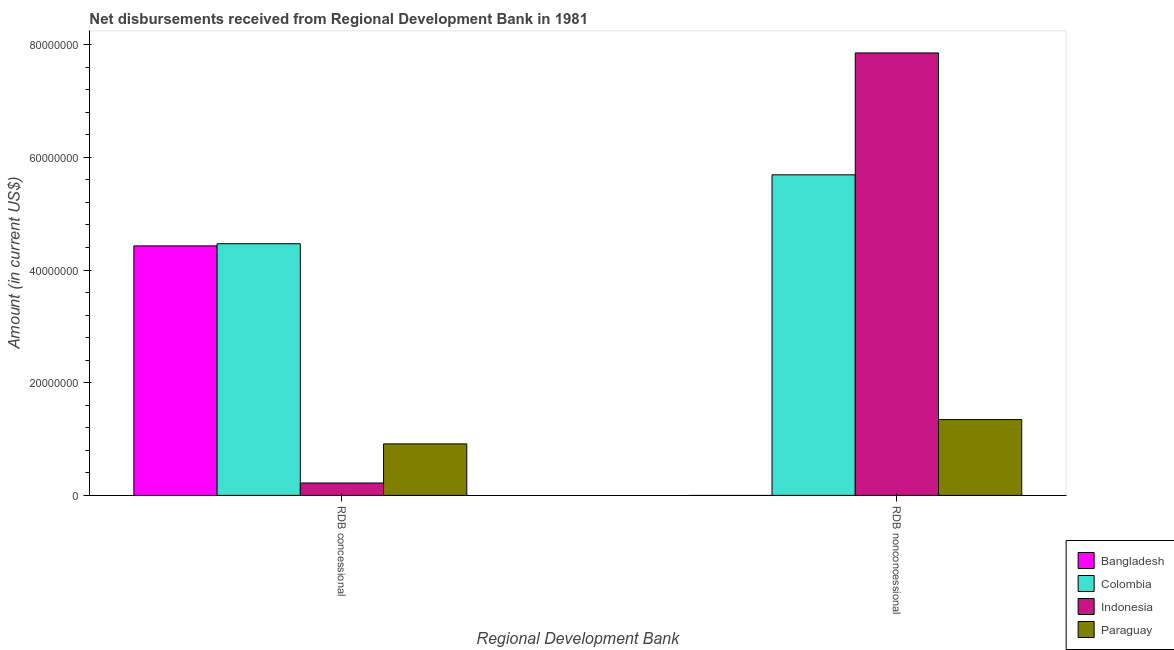How many different coloured bars are there?
Provide a short and direct response. 4. How many bars are there on the 2nd tick from the right?
Give a very brief answer. 4. What is the label of the 2nd group of bars from the left?
Offer a terse response. RDB nonconcessional. What is the net non concessional disbursements from rdb in Indonesia?
Make the answer very short. 7.85e+07. Across all countries, what is the maximum net non concessional disbursements from rdb?
Give a very brief answer. 7.85e+07. What is the total net concessional disbursements from rdb in the graph?
Your answer should be compact. 1.00e+08. What is the difference between the net non concessional disbursements from rdb in Colombia and that in Paraguay?
Ensure brevity in your answer.  4.34e+07. What is the difference between the net non concessional disbursements from rdb in Bangladesh and the net concessional disbursements from rdb in Colombia?
Offer a very short reply. -4.47e+07. What is the average net non concessional disbursements from rdb per country?
Ensure brevity in your answer.  3.72e+07. What is the difference between the net non concessional disbursements from rdb and net concessional disbursements from rdb in Paraguay?
Offer a very short reply. 4.32e+06. What is the ratio of the net concessional disbursements from rdb in Paraguay to that in Bangladesh?
Offer a terse response. 0.21. In how many countries, is the net non concessional disbursements from rdb greater than the average net non concessional disbursements from rdb taken over all countries?
Offer a terse response. 2. How many bars are there?
Your response must be concise. 7. How many countries are there in the graph?
Your response must be concise. 4. Does the graph contain any zero values?
Ensure brevity in your answer.  Yes. Where does the legend appear in the graph?
Provide a succinct answer. Bottom right. How many legend labels are there?
Provide a succinct answer. 4. How are the legend labels stacked?
Your answer should be very brief. Vertical. What is the title of the graph?
Keep it short and to the point. Net disbursements received from Regional Development Bank in 1981. Does "Mexico" appear as one of the legend labels in the graph?
Ensure brevity in your answer.  No. What is the label or title of the X-axis?
Keep it short and to the point. Regional Development Bank. What is the Amount (in current US$) of Bangladesh in RDB concessional?
Your answer should be compact. 4.43e+07. What is the Amount (in current US$) of Colombia in RDB concessional?
Your response must be concise. 4.47e+07. What is the Amount (in current US$) of Indonesia in RDB concessional?
Provide a succinct answer. 2.20e+06. What is the Amount (in current US$) in Paraguay in RDB concessional?
Provide a succinct answer. 9.14e+06. What is the Amount (in current US$) in Bangladesh in RDB nonconcessional?
Ensure brevity in your answer.  0. What is the Amount (in current US$) of Colombia in RDB nonconcessional?
Offer a terse response. 5.69e+07. What is the Amount (in current US$) in Indonesia in RDB nonconcessional?
Ensure brevity in your answer.  7.85e+07. What is the Amount (in current US$) of Paraguay in RDB nonconcessional?
Your response must be concise. 1.35e+07. Across all Regional Development Bank, what is the maximum Amount (in current US$) in Bangladesh?
Your answer should be compact. 4.43e+07. Across all Regional Development Bank, what is the maximum Amount (in current US$) in Colombia?
Ensure brevity in your answer.  5.69e+07. Across all Regional Development Bank, what is the maximum Amount (in current US$) in Indonesia?
Offer a terse response. 7.85e+07. Across all Regional Development Bank, what is the maximum Amount (in current US$) of Paraguay?
Your answer should be very brief. 1.35e+07. Across all Regional Development Bank, what is the minimum Amount (in current US$) in Colombia?
Make the answer very short. 4.47e+07. Across all Regional Development Bank, what is the minimum Amount (in current US$) of Indonesia?
Keep it short and to the point. 2.20e+06. Across all Regional Development Bank, what is the minimum Amount (in current US$) in Paraguay?
Offer a terse response. 9.14e+06. What is the total Amount (in current US$) in Bangladesh in the graph?
Offer a very short reply. 4.43e+07. What is the total Amount (in current US$) in Colombia in the graph?
Offer a very short reply. 1.02e+08. What is the total Amount (in current US$) of Indonesia in the graph?
Provide a succinct answer. 8.07e+07. What is the total Amount (in current US$) of Paraguay in the graph?
Provide a succinct answer. 2.26e+07. What is the difference between the Amount (in current US$) of Colombia in RDB concessional and that in RDB nonconcessional?
Provide a succinct answer. -1.22e+07. What is the difference between the Amount (in current US$) in Indonesia in RDB concessional and that in RDB nonconcessional?
Give a very brief answer. -7.63e+07. What is the difference between the Amount (in current US$) of Paraguay in RDB concessional and that in RDB nonconcessional?
Your answer should be compact. -4.32e+06. What is the difference between the Amount (in current US$) of Bangladesh in RDB concessional and the Amount (in current US$) of Colombia in RDB nonconcessional?
Ensure brevity in your answer.  -1.26e+07. What is the difference between the Amount (in current US$) in Bangladesh in RDB concessional and the Amount (in current US$) in Indonesia in RDB nonconcessional?
Offer a very short reply. -3.42e+07. What is the difference between the Amount (in current US$) in Bangladesh in RDB concessional and the Amount (in current US$) in Paraguay in RDB nonconcessional?
Make the answer very short. 3.08e+07. What is the difference between the Amount (in current US$) of Colombia in RDB concessional and the Amount (in current US$) of Indonesia in RDB nonconcessional?
Provide a succinct answer. -3.39e+07. What is the difference between the Amount (in current US$) of Colombia in RDB concessional and the Amount (in current US$) of Paraguay in RDB nonconcessional?
Make the answer very short. 3.12e+07. What is the difference between the Amount (in current US$) of Indonesia in RDB concessional and the Amount (in current US$) of Paraguay in RDB nonconcessional?
Keep it short and to the point. -1.13e+07. What is the average Amount (in current US$) in Bangladesh per Regional Development Bank?
Your response must be concise. 2.21e+07. What is the average Amount (in current US$) in Colombia per Regional Development Bank?
Keep it short and to the point. 5.08e+07. What is the average Amount (in current US$) in Indonesia per Regional Development Bank?
Keep it short and to the point. 4.04e+07. What is the average Amount (in current US$) in Paraguay per Regional Development Bank?
Give a very brief answer. 1.13e+07. What is the difference between the Amount (in current US$) in Bangladesh and Amount (in current US$) in Colombia in RDB concessional?
Offer a terse response. -3.84e+05. What is the difference between the Amount (in current US$) of Bangladesh and Amount (in current US$) of Indonesia in RDB concessional?
Your answer should be very brief. 4.21e+07. What is the difference between the Amount (in current US$) in Bangladesh and Amount (in current US$) in Paraguay in RDB concessional?
Your answer should be very brief. 3.51e+07. What is the difference between the Amount (in current US$) in Colombia and Amount (in current US$) in Indonesia in RDB concessional?
Offer a very short reply. 4.25e+07. What is the difference between the Amount (in current US$) in Colombia and Amount (in current US$) in Paraguay in RDB concessional?
Keep it short and to the point. 3.55e+07. What is the difference between the Amount (in current US$) of Indonesia and Amount (in current US$) of Paraguay in RDB concessional?
Give a very brief answer. -6.94e+06. What is the difference between the Amount (in current US$) of Colombia and Amount (in current US$) of Indonesia in RDB nonconcessional?
Your answer should be compact. -2.16e+07. What is the difference between the Amount (in current US$) in Colombia and Amount (in current US$) in Paraguay in RDB nonconcessional?
Offer a very short reply. 4.34e+07. What is the difference between the Amount (in current US$) of Indonesia and Amount (in current US$) of Paraguay in RDB nonconcessional?
Provide a short and direct response. 6.51e+07. What is the ratio of the Amount (in current US$) in Colombia in RDB concessional to that in RDB nonconcessional?
Provide a succinct answer. 0.79. What is the ratio of the Amount (in current US$) in Indonesia in RDB concessional to that in RDB nonconcessional?
Offer a terse response. 0.03. What is the ratio of the Amount (in current US$) of Paraguay in RDB concessional to that in RDB nonconcessional?
Offer a very short reply. 0.68. What is the difference between the highest and the second highest Amount (in current US$) of Colombia?
Offer a terse response. 1.22e+07. What is the difference between the highest and the second highest Amount (in current US$) of Indonesia?
Your response must be concise. 7.63e+07. What is the difference between the highest and the second highest Amount (in current US$) of Paraguay?
Your response must be concise. 4.32e+06. What is the difference between the highest and the lowest Amount (in current US$) in Bangladesh?
Offer a terse response. 4.43e+07. What is the difference between the highest and the lowest Amount (in current US$) of Colombia?
Offer a very short reply. 1.22e+07. What is the difference between the highest and the lowest Amount (in current US$) of Indonesia?
Offer a very short reply. 7.63e+07. What is the difference between the highest and the lowest Amount (in current US$) of Paraguay?
Your answer should be very brief. 4.32e+06. 